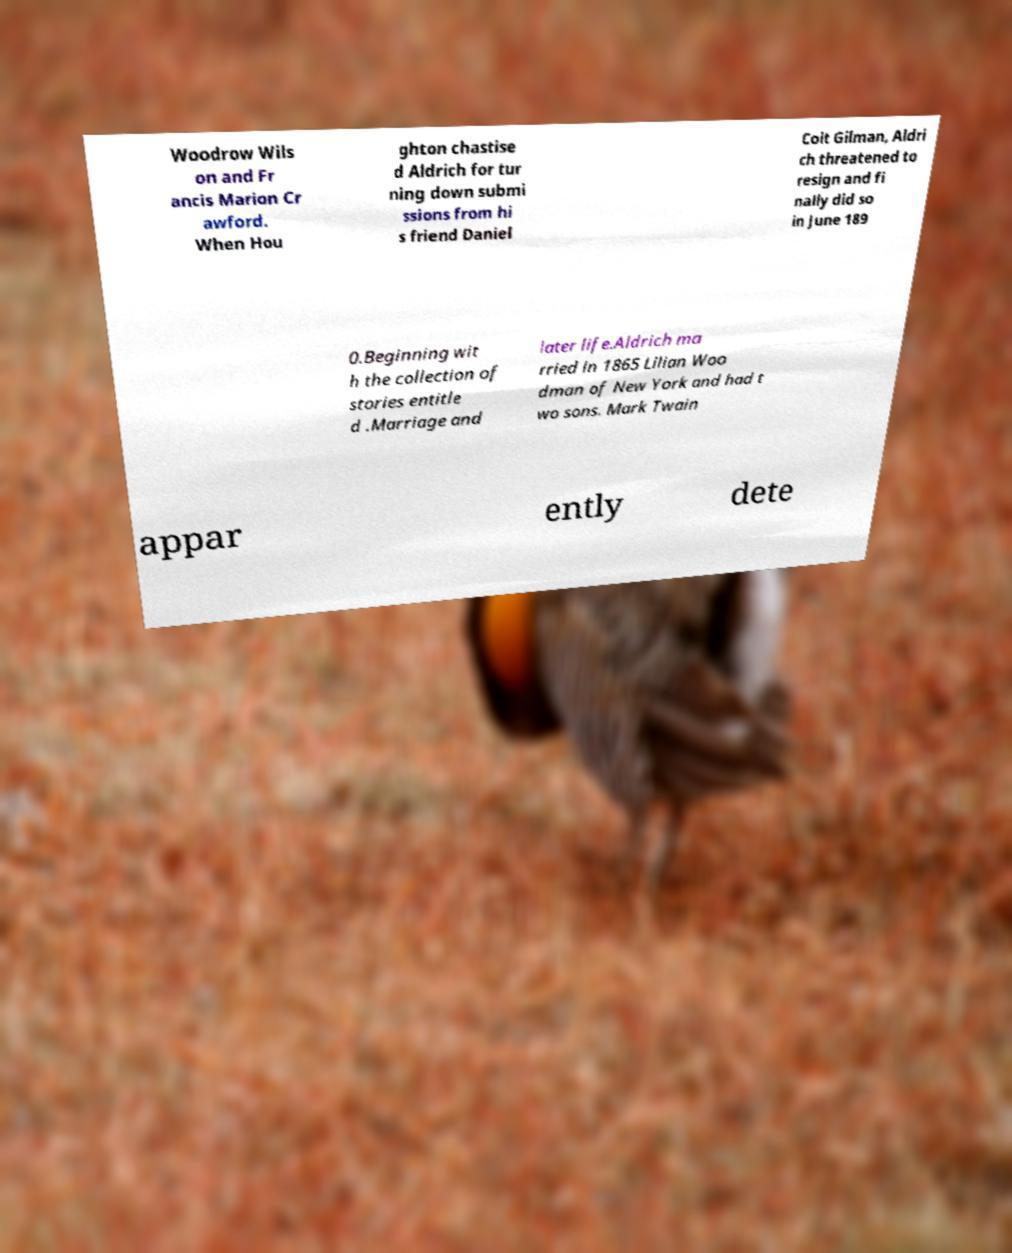Could you assist in decoding the text presented in this image and type it out clearly? Woodrow Wils on and Fr ancis Marion Cr awford. When Hou ghton chastise d Aldrich for tur ning down submi ssions from hi s friend Daniel Coit Gilman, Aldri ch threatened to resign and fi nally did so in June 189 0.Beginning wit h the collection of stories entitle d .Marriage and later life.Aldrich ma rried in 1865 Lilian Woo dman of New York and had t wo sons. Mark Twain appar ently dete 